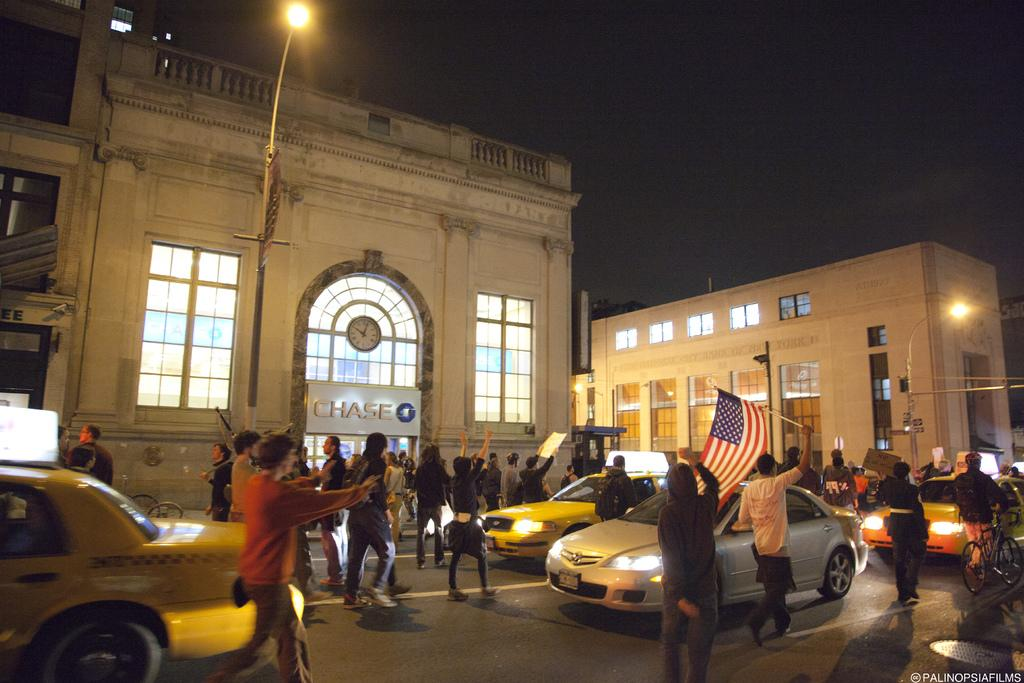<image>
Present a compact description of the photo's key features. People marching the streets in protest in front of the Chase building. 